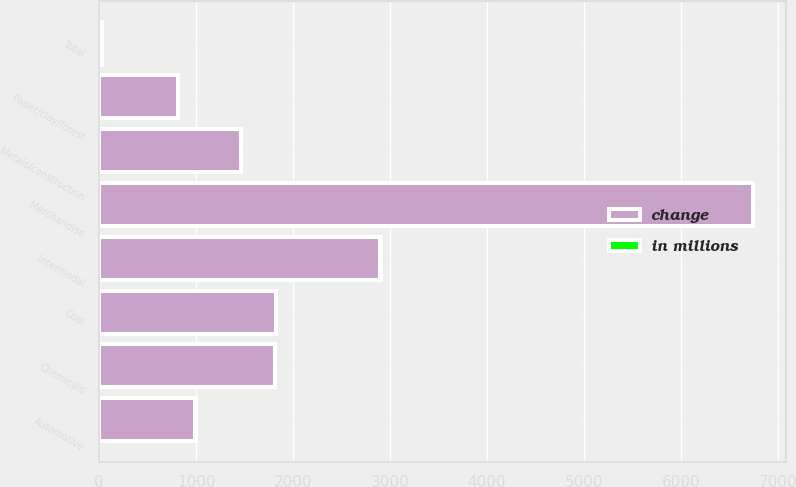<chart> <loc_0><loc_0><loc_500><loc_500><stacked_bar_chart><ecel><fcel>Chemicals<fcel>Metals/construction<fcel>Automotive<fcel>Paper/clay/forest<fcel>Merchandise<fcel>Intermodal<fcel>Coal<fcel>Total<nl><fcel>change<fcel>1808<fcel>1462<fcel>991<fcel>809<fcel>6744<fcel>2893<fcel>1821<fcel>18<nl><fcel>in millions<fcel>8<fcel>3<fcel>4<fcel>6<fcel>6<fcel>18<fcel>5<fcel>9<nl></chart> 